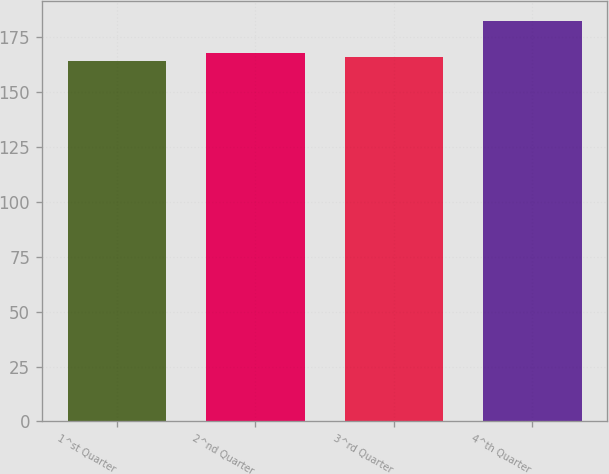Convert chart. <chart><loc_0><loc_0><loc_500><loc_500><bar_chart><fcel>1^st Quarter<fcel>2^nd Quarter<fcel>3^rd Quarter<fcel>4^th Quarter<nl><fcel>164<fcel>167.62<fcel>165.81<fcel>182.11<nl></chart> 